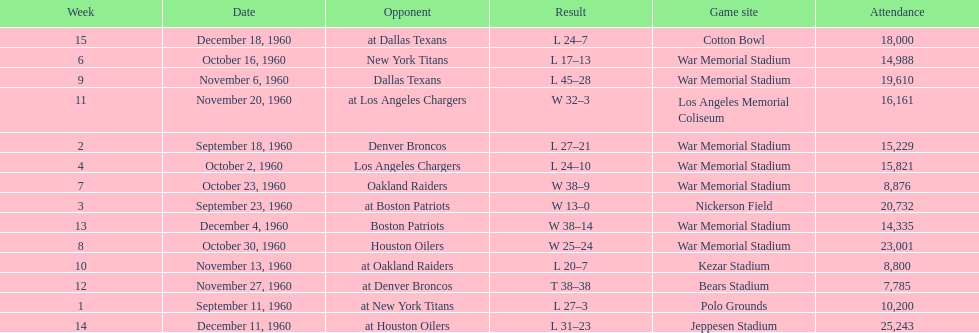Which date had the highest attendance? December 11, 1960. 